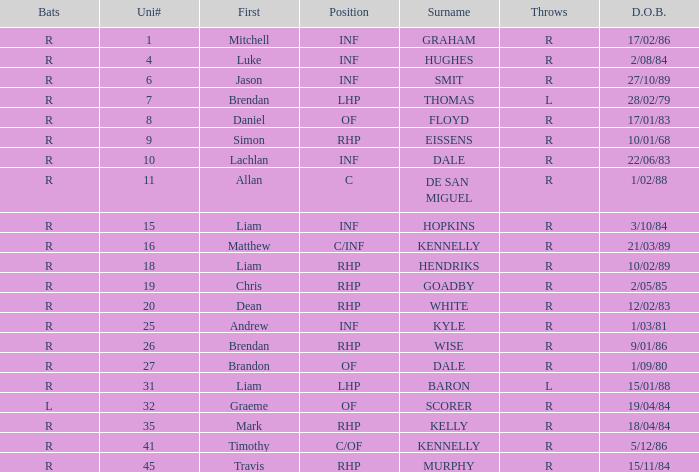Which batter has a uni# of 31? R. 